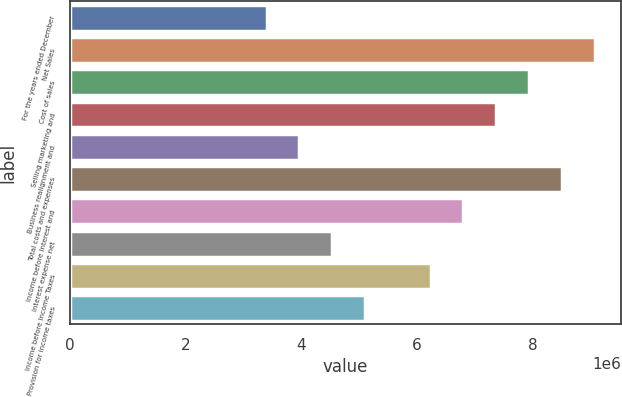<chart> <loc_0><loc_0><loc_500><loc_500><bar_chart><fcel>For the years ended December<fcel>Net Sales<fcel>Cost of sales<fcel>Selling marketing and<fcel>Business realignment and<fcel>Total costs and expenses<fcel>Income before Interest and<fcel>Interest expense net<fcel>Income before Income Taxes<fcel>Provision for income taxes<nl><fcel>3.40261e+06<fcel>9.07361e+06<fcel>7.93941e+06<fcel>7.37231e+06<fcel>3.96971e+06<fcel>8.50651e+06<fcel>6.80521e+06<fcel>4.53681e+06<fcel>6.23811e+06<fcel>5.10391e+06<nl></chart> 